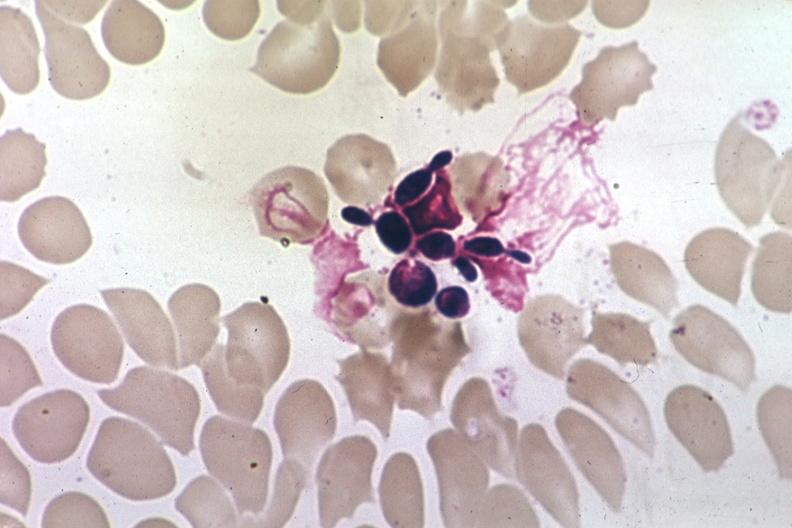s squamous cell carcinoma present?
Answer the question using a single word or phrase. No 